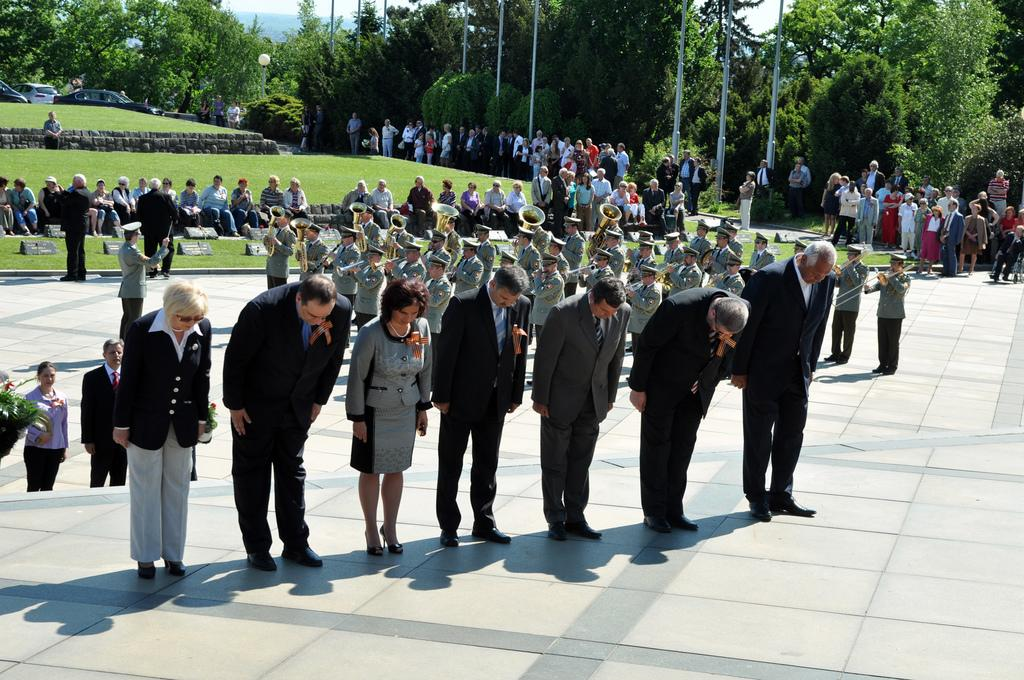What are the people in the image doing? There are people standing, sitting, and holding musical instruments in the image. Can you describe the background of the image? There are trees, poles, and vehicles visible in the background of the image. What is the rate of steam produced by the people holding musical instruments in the image? There is no steam produced by the people holding musical instruments in the image, as steam is not related to playing musical instruments. 